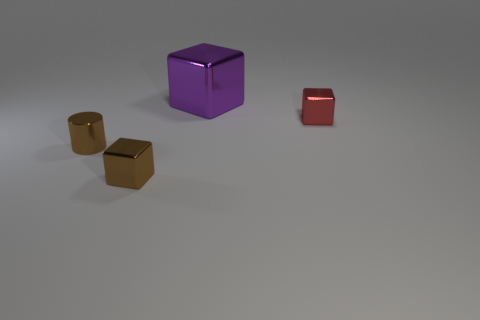Is there a metallic cylinder that has the same size as the red cube?
Ensure brevity in your answer.  Yes. The big cube that is made of the same material as the tiny red cube is what color?
Your answer should be very brief. Purple. There is a brown metal block in front of the purple metal cube; what number of red blocks are behind it?
Give a very brief answer. 1. What material is the object that is to the right of the tiny brown metal cylinder and in front of the red block?
Make the answer very short. Metal. Does the small brown thing on the left side of the tiny brown block have the same shape as the big purple thing?
Your response must be concise. No. Is the number of red metal blocks less than the number of cyan objects?
Give a very brief answer. No. How many big shiny blocks have the same color as the small cylinder?
Your response must be concise. 0. What is the material of the object that is the same color as the metallic cylinder?
Make the answer very short. Metal. Does the large metallic thing have the same color as the cube that is in front of the small metal cylinder?
Provide a succinct answer. No. Are there more big cyan metallic cylinders than brown metallic blocks?
Keep it short and to the point. No. 